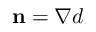<formula> <loc_0><loc_0><loc_500><loc_500>\mathbf n = \nabla d</formula> 